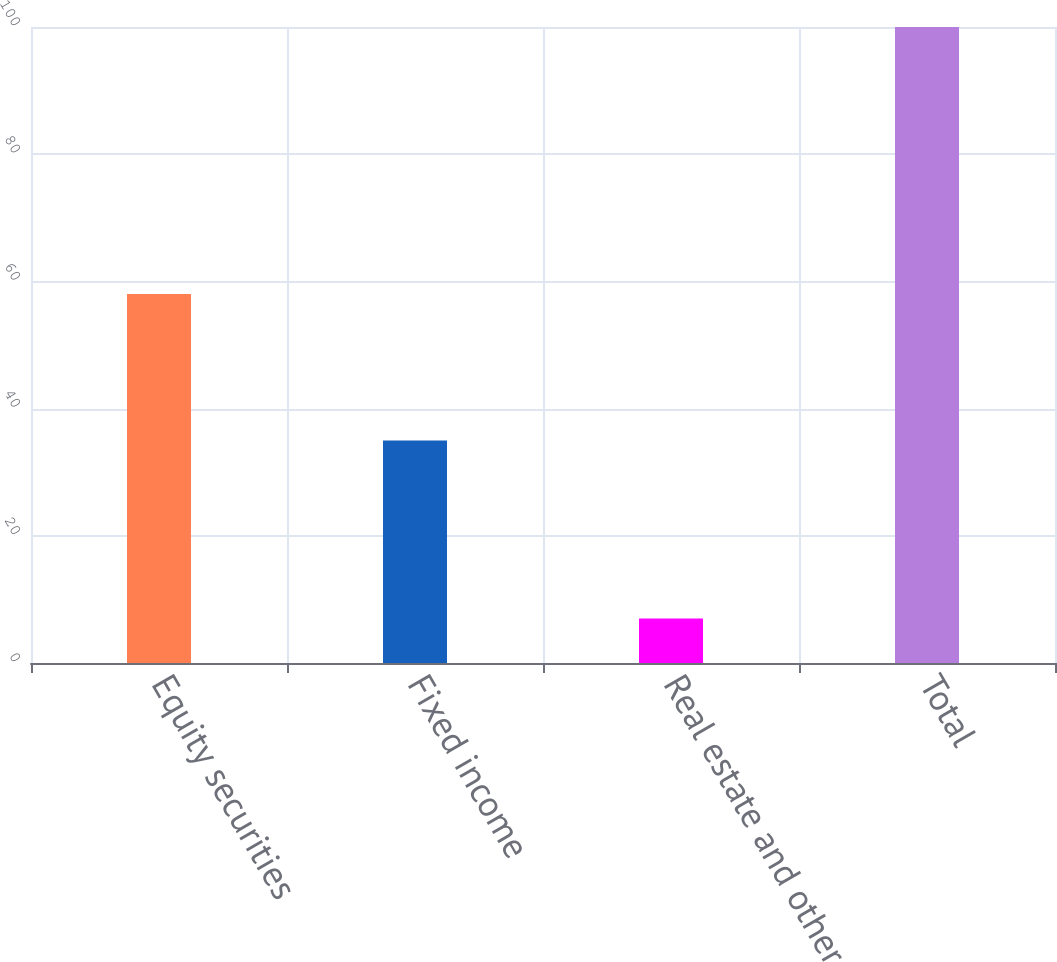Convert chart to OTSL. <chart><loc_0><loc_0><loc_500><loc_500><bar_chart><fcel>Equity securities<fcel>Fixed income<fcel>Real estate and other<fcel>Total<nl><fcel>58<fcel>35<fcel>7<fcel>100<nl></chart> 